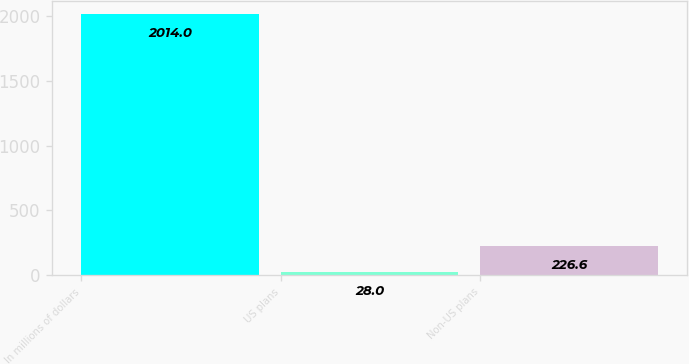Convert chart. <chart><loc_0><loc_0><loc_500><loc_500><bar_chart><fcel>In millions of dollars<fcel>US plans<fcel>Non-US plans<nl><fcel>2014<fcel>28<fcel>226.6<nl></chart> 